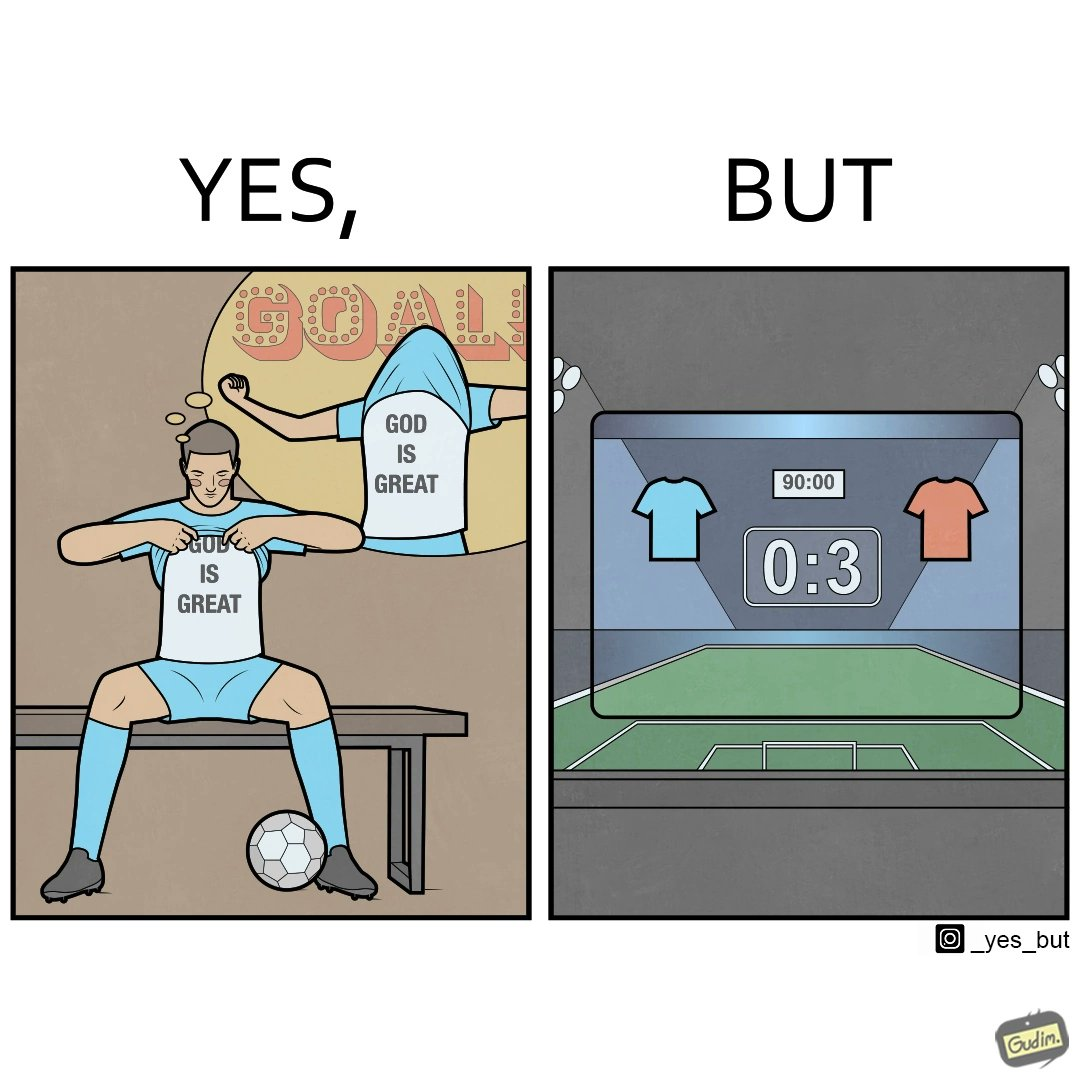Explain why this image is satirical. The image is funny because the player thinks that when he scores a goal he will thank the god and show his t-shirt saying "GOD IS GREAT" but he ends up not being able to score any goals meaning that God did not want him to score any goals. 